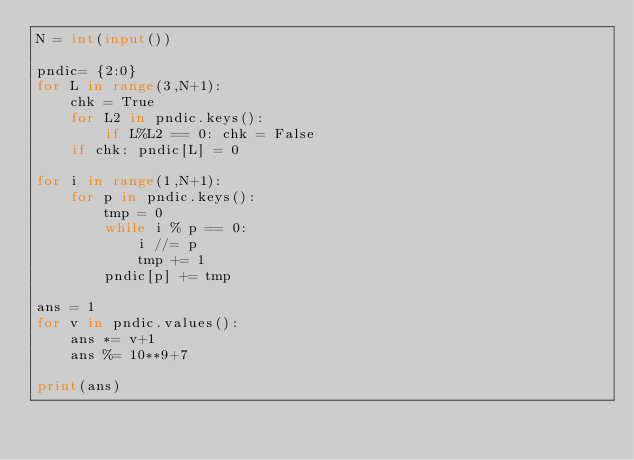Convert code to text. <code><loc_0><loc_0><loc_500><loc_500><_Python_>N = int(input())

pndic= {2:0}
for L in range(3,N+1):
    chk = True
    for L2 in pndic.keys():
        if L%L2 == 0: chk = False
    if chk: pndic[L] = 0

for i in range(1,N+1):
    for p in pndic.keys():
        tmp = 0
        while i % p == 0:
            i //= p
            tmp += 1
        pndic[p] += tmp

ans = 1
for v in pndic.values():
    ans *= v+1
    ans %= 10**9+7

print(ans)</code> 